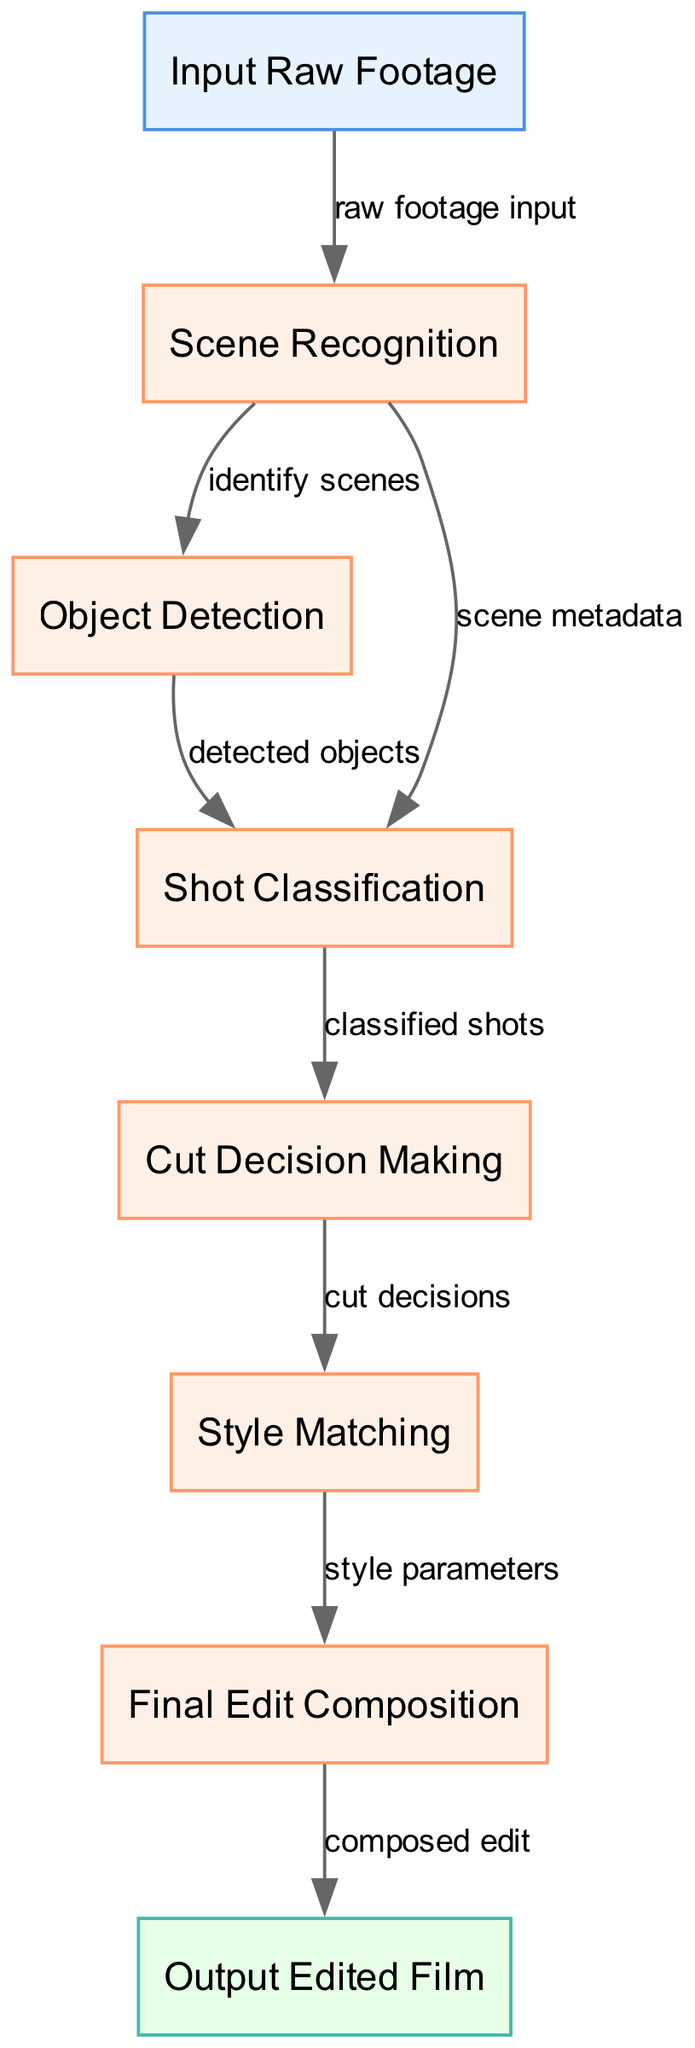What is the first step in the diagram? The diagram starts with "Input Raw Footage," which is indicated as the first node in the pipeline.
Answer: Input Raw Footage How many processes are depicted in the diagram? There are six process nodes shown in the diagram: Scene Recognition, Object Detection, Shot Classification, Cut Decision Making, Style Matching, and Final Edit Composition, which counts to six.
Answer: Six What type of node is "Output Edited Film"? "Output Edited Film" is categorized as a data output node, which is clearly marked as such according to the node types.
Answer: Data output What connects "Scene Recognition" to "Cut Decision Making"? The edge labeled "cut decisions" connects these two nodes, indicating the flow of information between them.
Answer: Cut decisions Which process node follows "Style Matching"? The process node that follows "Style Matching" is "Final Edit Composition," as depicted through the directional edge in the diagram.
Answer: Final Edit Composition How many edges are present in the diagram? The diagram features a total of seven edges, based on the connections between the input node and all processes leading to the output.
Answer: Seven What is the role of "Object Detection" in the pipeline? "Object Detection" plays a crucial role as it follows "Scene Recognition" and provides detected objects to the subsequent "Shot Classification" process.
Answer: Provide detected objects How is the "Cut Decision Making" node reached in the flow? "Cut Decision Making" is reached from "Shot Classification," where classified shots inform the cut decisions as shown in the edge connection.
Answer: From Shot Classification 